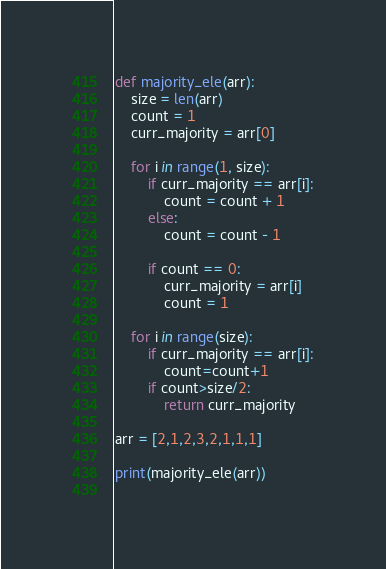Convert code to text. <code><loc_0><loc_0><loc_500><loc_500><_Python_>def majority_ele(arr):
    size = len(arr)
    count = 1 
    curr_majority = arr[0]
    
    for i in range(1, size):
        if curr_majority == arr[i]:
            count = count + 1
        else:
            count = count - 1
            
        if count == 0:
            curr_majority = arr[i]
            count = 1 
            
    for i in range(size):
        if curr_majority == arr[i]:
            count=count+1
        if count>size/2:
            return curr_majority
            
arr = [2,1,2,3,2,1,1,1]

print(majority_ele(arr))
    </code> 